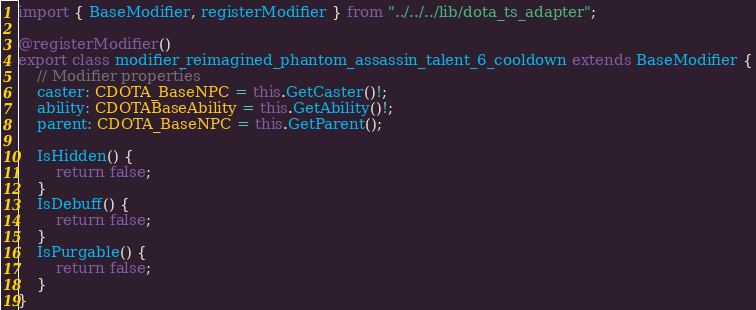Convert code to text. <code><loc_0><loc_0><loc_500><loc_500><_TypeScript_>import { BaseModifier, registerModifier } from "../../../lib/dota_ts_adapter";

@registerModifier()
export class modifier_reimagined_phantom_assassin_talent_6_cooldown extends BaseModifier {
	// Modifier properties
	caster: CDOTA_BaseNPC = this.GetCaster()!;
	ability: CDOTABaseAbility = this.GetAbility()!;
	parent: CDOTA_BaseNPC = this.GetParent();

	IsHidden() {
		return false;
	}
	IsDebuff() {
		return false;
	}
	IsPurgable() {
		return false;
	}
}
</code> 